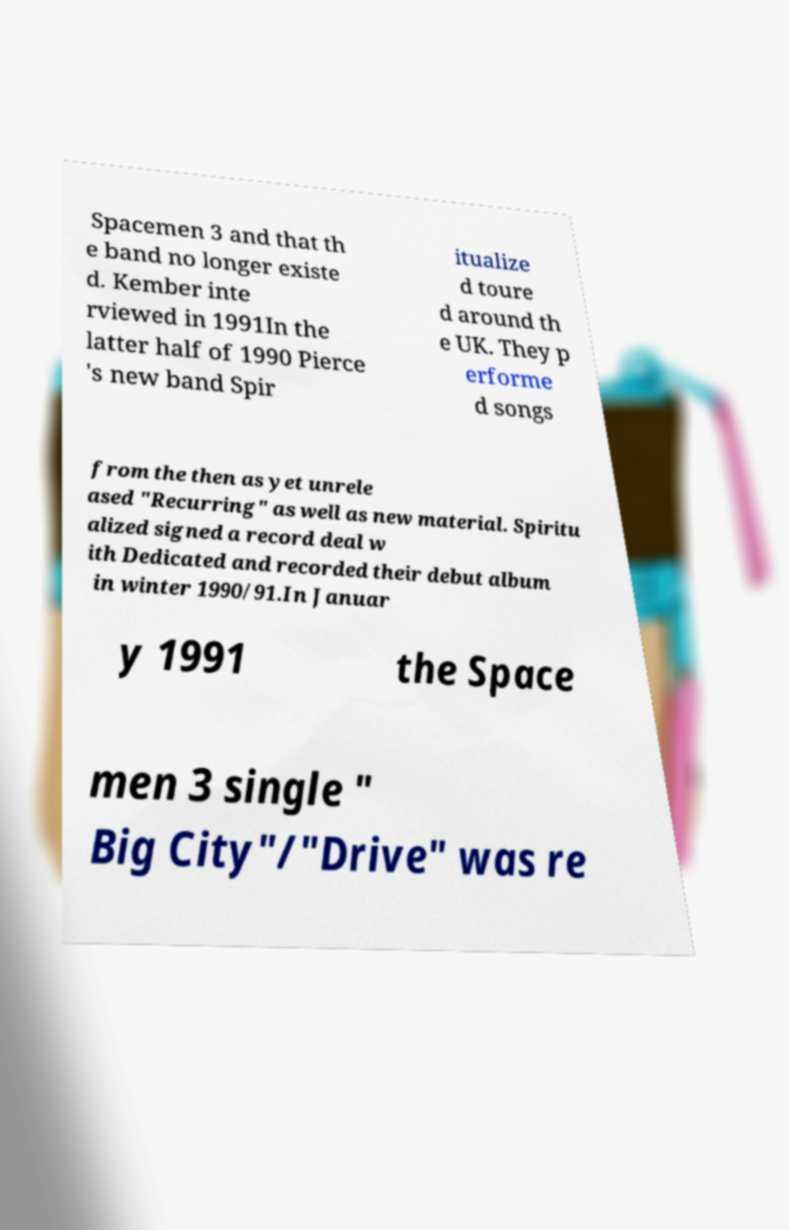Could you extract and type out the text from this image? Spacemen 3 and that th e band no longer existe d. Kember inte rviewed in 1991In the latter half of 1990 Pierce 's new band Spir itualize d toure d around th e UK. They p erforme d songs from the then as yet unrele ased "Recurring" as well as new material. Spiritu alized signed a record deal w ith Dedicated and recorded their debut album in winter 1990/91.In Januar y 1991 the Space men 3 single " Big City"/"Drive" was re 